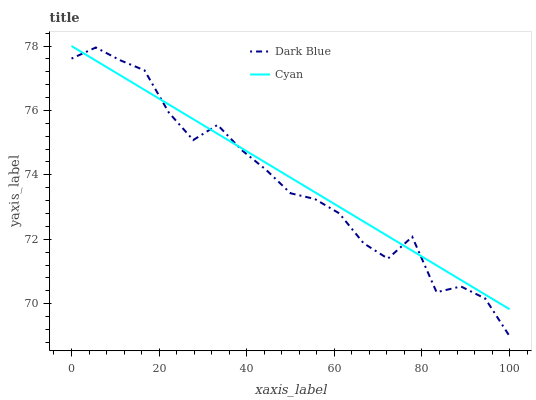Does Dark Blue have the minimum area under the curve?
Answer yes or no. Yes. Does Cyan have the maximum area under the curve?
Answer yes or no. Yes. Does Cyan have the minimum area under the curve?
Answer yes or no. No. Is Cyan the smoothest?
Answer yes or no. Yes. Is Dark Blue the roughest?
Answer yes or no. Yes. Is Cyan the roughest?
Answer yes or no. No. Does Dark Blue have the lowest value?
Answer yes or no. Yes. Does Cyan have the lowest value?
Answer yes or no. No. Does Cyan have the highest value?
Answer yes or no. Yes. Does Cyan intersect Dark Blue?
Answer yes or no. Yes. Is Cyan less than Dark Blue?
Answer yes or no. No. Is Cyan greater than Dark Blue?
Answer yes or no. No. 